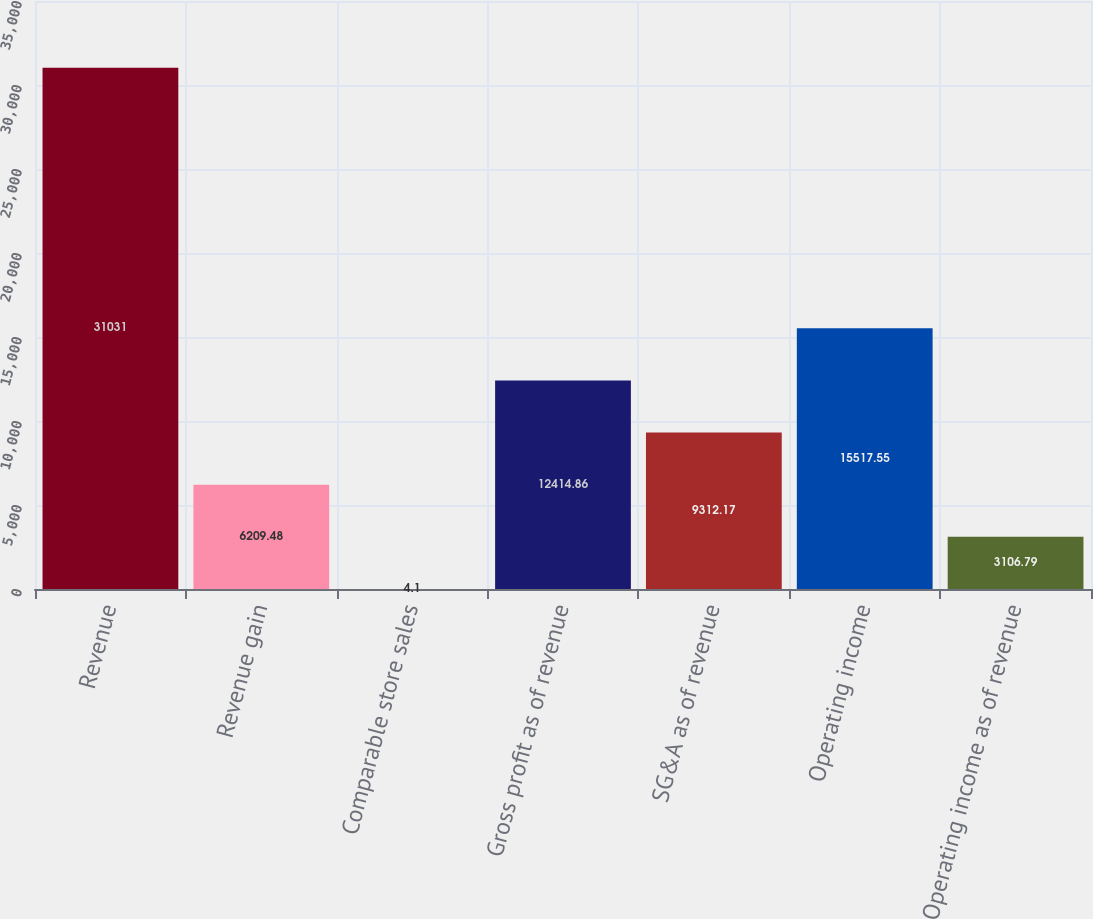Convert chart to OTSL. <chart><loc_0><loc_0><loc_500><loc_500><bar_chart><fcel>Revenue<fcel>Revenue gain<fcel>Comparable store sales<fcel>Gross profit as of revenue<fcel>SG&A as of revenue<fcel>Operating income<fcel>Operating income as of revenue<nl><fcel>31031<fcel>6209.48<fcel>4.1<fcel>12414.9<fcel>9312.17<fcel>15517.5<fcel>3106.79<nl></chart> 